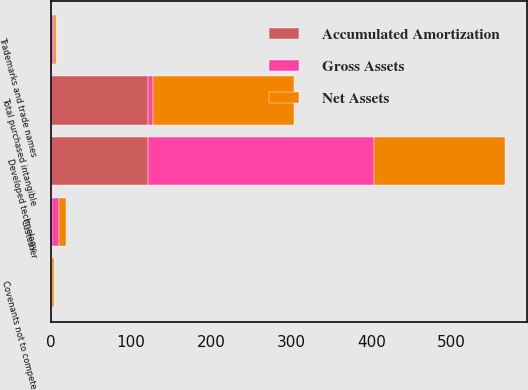Convert chart to OTSL. <chart><loc_0><loc_0><loc_500><loc_500><stacked_bar_chart><ecel><fcel>Developed technology<fcel>Customer<fcel>Trademarks and trade names<fcel>Covenants not to compete<fcel>Total purchased intangible<nl><fcel>Gross Assets<fcel>283<fcel>9.6<fcel>2.9<fcel>1.6<fcel>5.95<nl><fcel>Net Assets<fcel>162.6<fcel>9<fcel>2.4<fcel>1.6<fcel>175.6<nl><fcel>Accumulated Amortization<fcel>120.4<fcel>0.6<fcel>0.5<fcel>0<fcel>121.5<nl></chart> 